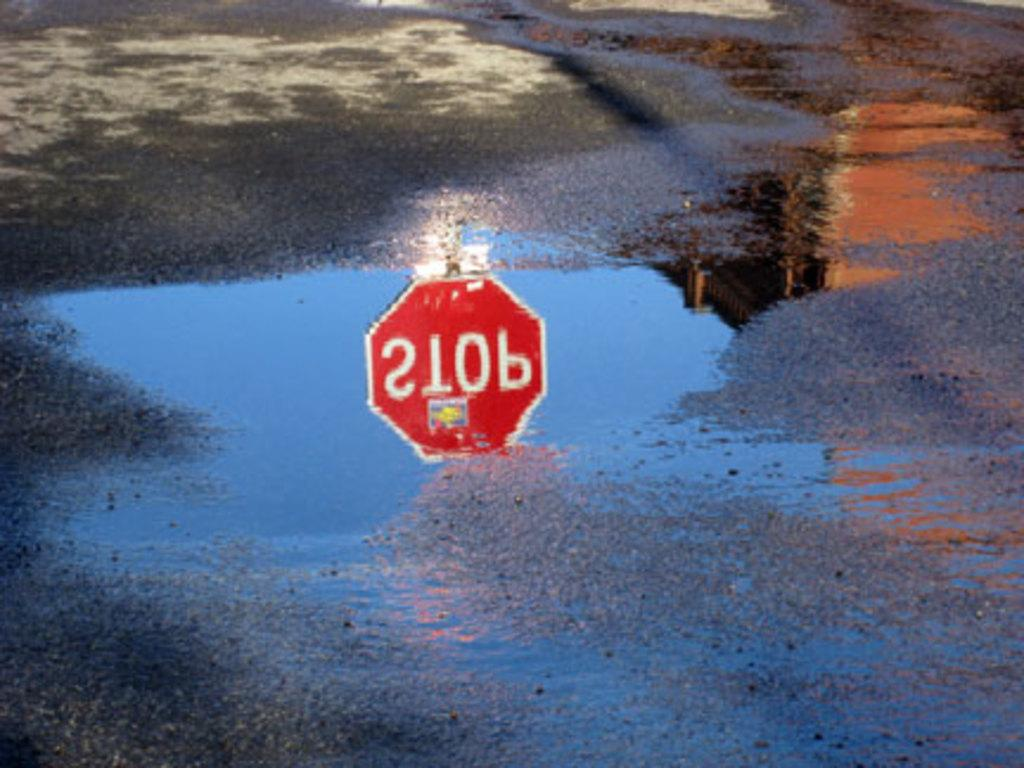<image>
Write a terse but informative summary of the picture. A stop sign can be seen reflected in the water. 